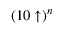<formula> <loc_0><loc_0><loc_500><loc_500>( 1 0 \uparrow ) ^ { n }</formula> 